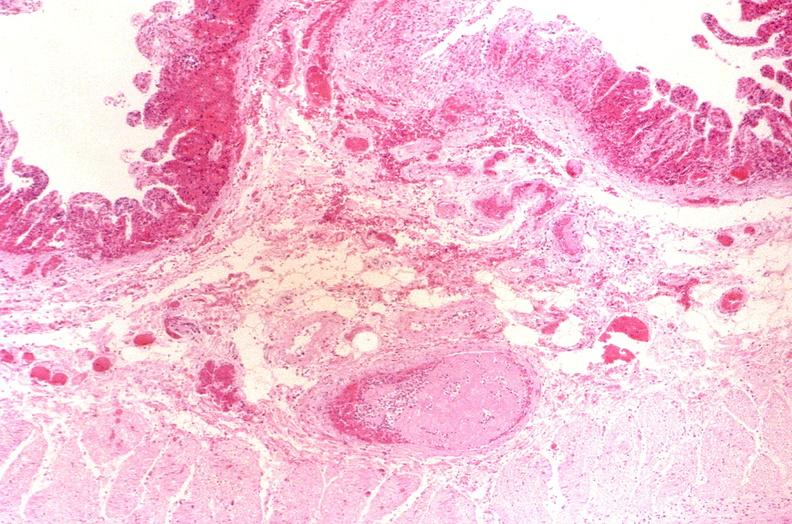what does this image show?
Answer the question using a single word or phrase. Thrombosed esophageal varices 